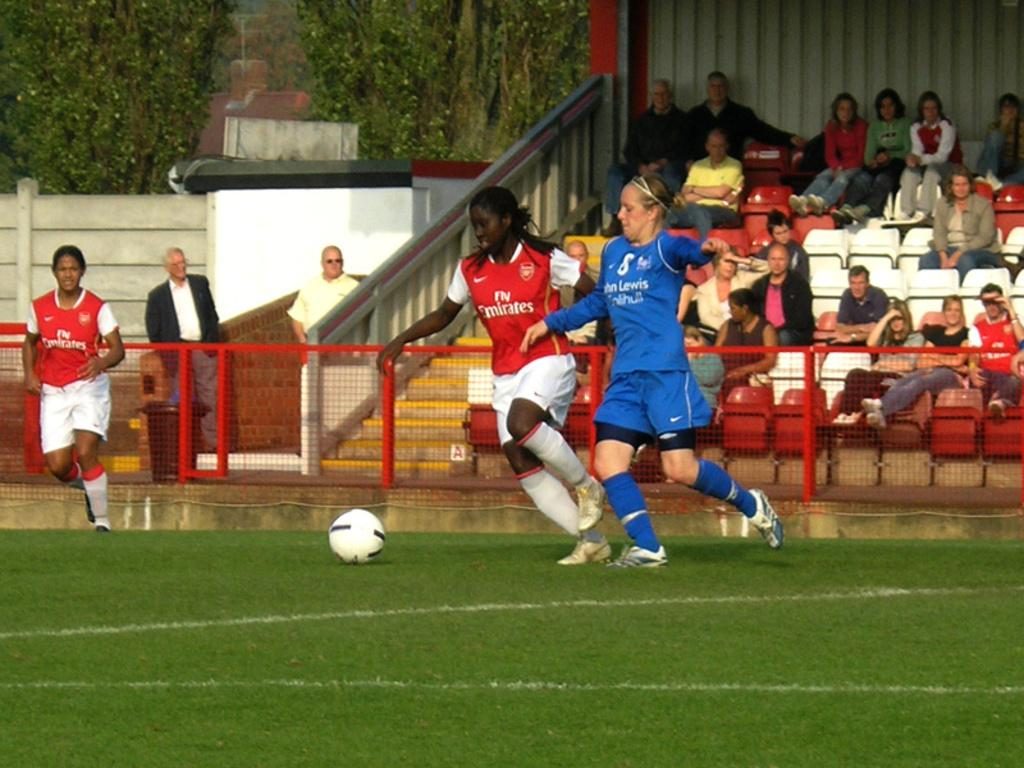Provide a one-sentence caption for the provided image. A chelsea FC womans player tackles an Arsenal player in front of a small crowd... 